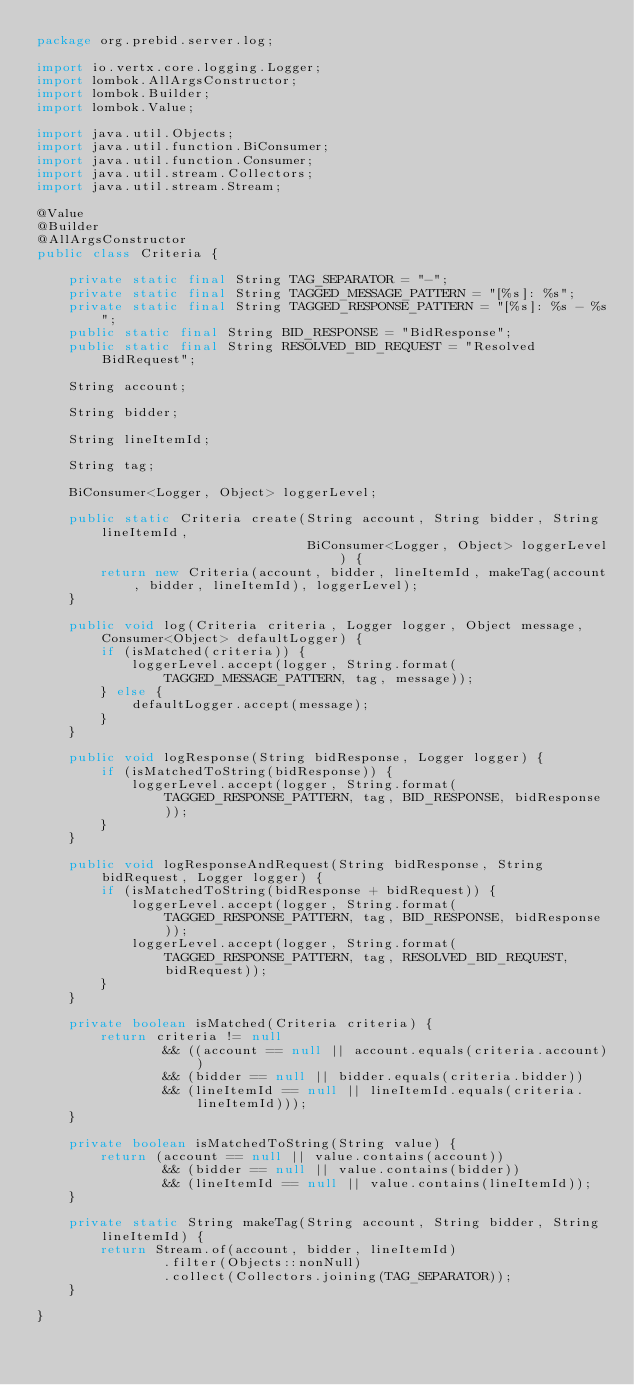<code> <loc_0><loc_0><loc_500><loc_500><_Java_>package org.prebid.server.log;

import io.vertx.core.logging.Logger;
import lombok.AllArgsConstructor;
import lombok.Builder;
import lombok.Value;

import java.util.Objects;
import java.util.function.BiConsumer;
import java.util.function.Consumer;
import java.util.stream.Collectors;
import java.util.stream.Stream;

@Value
@Builder
@AllArgsConstructor
public class Criteria {

    private static final String TAG_SEPARATOR = "-";
    private static final String TAGGED_MESSAGE_PATTERN = "[%s]: %s";
    private static final String TAGGED_RESPONSE_PATTERN = "[%s]: %s - %s";
    public static final String BID_RESPONSE = "BidResponse";
    public static final String RESOLVED_BID_REQUEST = "Resolved BidRequest";

    String account;

    String bidder;

    String lineItemId;

    String tag;

    BiConsumer<Logger, Object> loggerLevel;

    public static Criteria create(String account, String bidder, String lineItemId,
                                  BiConsumer<Logger, Object> loggerLevel) {
        return new Criteria(account, bidder, lineItemId, makeTag(account, bidder, lineItemId), loggerLevel);
    }

    public void log(Criteria criteria, Logger logger, Object message, Consumer<Object> defaultLogger) {
        if (isMatched(criteria)) {
            loggerLevel.accept(logger, String.format(TAGGED_MESSAGE_PATTERN, tag, message));
        } else {
            defaultLogger.accept(message);
        }
    }

    public void logResponse(String bidResponse, Logger logger) {
        if (isMatchedToString(bidResponse)) {
            loggerLevel.accept(logger, String.format(TAGGED_RESPONSE_PATTERN, tag, BID_RESPONSE, bidResponse));
        }
    }

    public void logResponseAndRequest(String bidResponse, String bidRequest, Logger logger) {
        if (isMatchedToString(bidResponse + bidRequest)) {
            loggerLevel.accept(logger, String.format(TAGGED_RESPONSE_PATTERN, tag, BID_RESPONSE, bidResponse));
            loggerLevel.accept(logger, String.format(TAGGED_RESPONSE_PATTERN, tag, RESOLVED_BID_REQUEST, bidRequest));
        }
    }

    private boolean isMatched(Criteria criteria) {
        return criteria != null
                && ((account == null || account.equals(criteria.account))
                && (bidder == null || bidder.equals(criteria.bidder))
                && (lineItemId == null || lineItemId.equals(criteria.lineItemId)));
    }

    private boolean isMatchedToString(String value) {
        return (account == null || value.contains(account))
                && (bidder == null || value.contains(bidder))
                && (lineItemId == null || value.contains(lineItemId));
    }

    private static String makeTag(String account, String bidder, String lineItemId) {
        return Stream.of(account, bidder, lineItemId)
                .filter(Objects::nonNull)
                .collect(Collectors.joining(TAG_SEPARATOR));
    }

}
</code> 